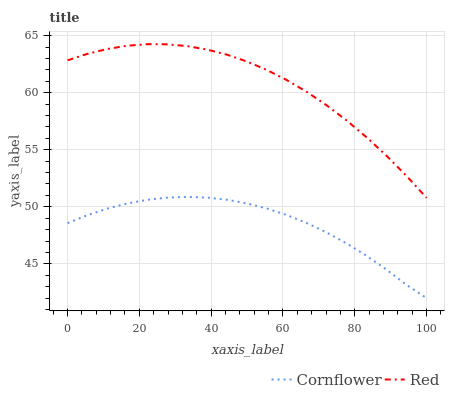Does Cornflower have the minimum area under the curve?
Answer yes or no. Yes. Does Red have the maximum area under the curve?
Answer yes or no. Yes. Does Red have the minimum area under the curve?
Answer yes or no. No. Is Cornflower the smoothest?
Answer yes or no. Yes. Is Red the roughest?
Answer yes or no. Yes. Is Red the smoothest?
Answer yes or no. No. Does Cornflower have the lowest value?
Answer yes or no. Yes. Does Red have the lowest value?
Answer yes or no. No. Does Red have the highest value?
Answer yes or no. Yes. Is Cornflower less than Red?
Answer yes or no. Yes. Is Red greater than Cornflower?
Answer yes or no. Yes. Does Cornflower intersect Red?
Answer yes or no. No. 